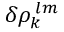<formula> <loc_0><loc_0><loc_500><loc_500>\delta \rho _ { k } ^ { \, l m }</formula> 